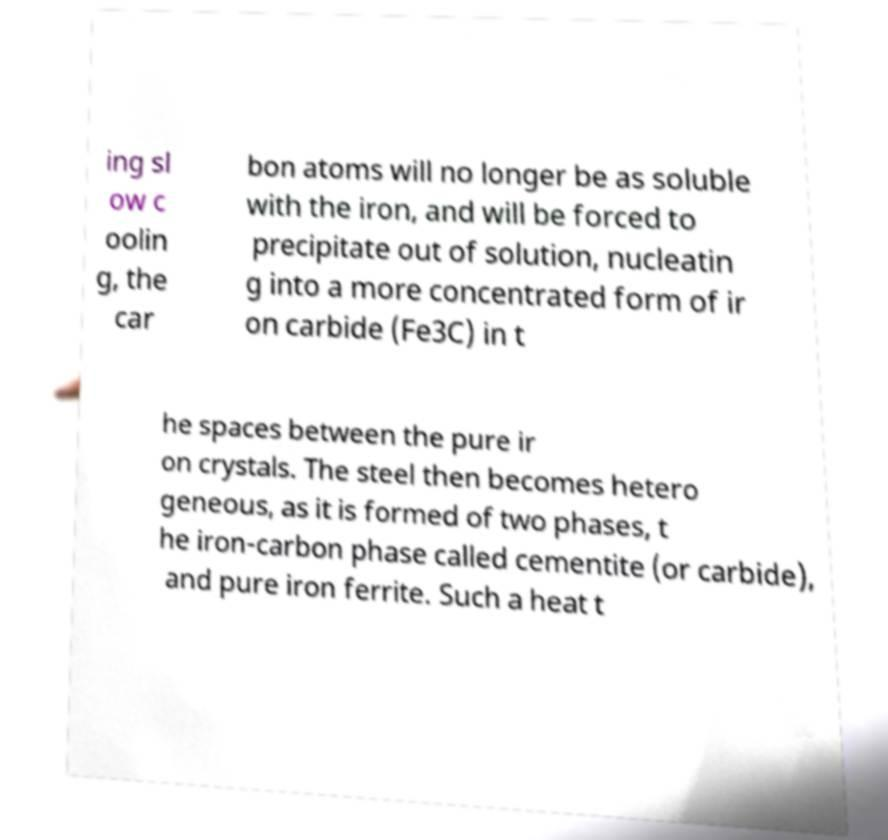Could you extract and type out the text from this image? ing sl ow c oolin g, the car bon atoms will no longer be as soluble with the iron, and will be forced to precipitate out of solution, nucleatin g into a more concentrated form of ir on carbide (Fe3C) in t he spaces between the pure ir on crystals. The steel then becomes hetero geneous, as it is formed of two phases, t he iron-carbon phase called cementite (or carbide), and pure iron ferrite. Such a heat t 